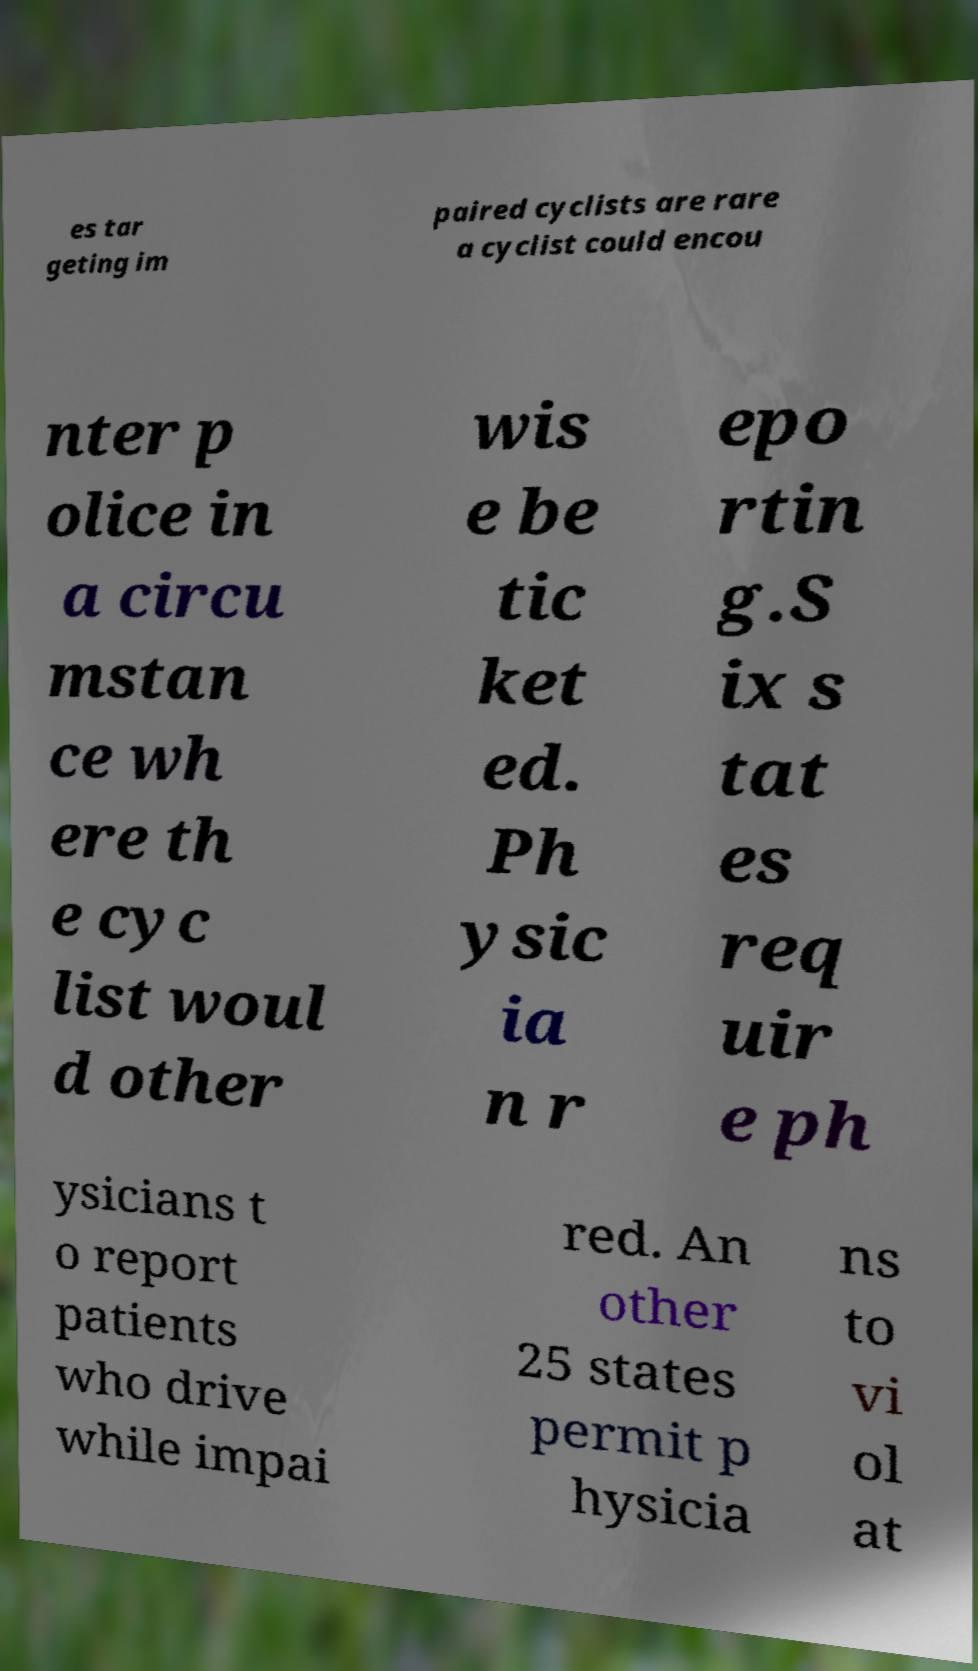There's text embedded in this image that I need extracted. Can you transcribe it verbatim? es tar geting im paired cyclists are rare a cyclist could encou nter p olice in a circu mstan ce wh ere th e cyc list woul d other wis e be tic ket ed. Ph ysic ia n r epo rtin g.S ix s tat es req uir e ph ysicians t o report patients who drive while impai red. An other 25 states permit p hysicia ns to vi ol at 